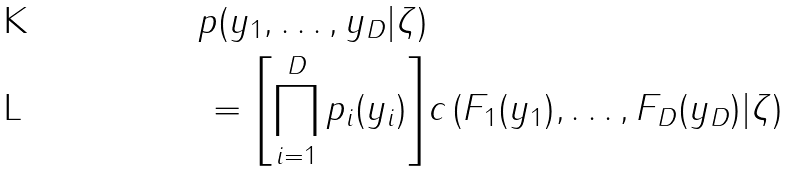Convert formula to latex. <formula><loc_0><loc_0><loc_500><loc_500>p ( y _ { 1 } , \dots , y _ { D } | \zeta ) \\ = \left [ \prod _ { i = 1 } ^ { D } p _ { i } ( y _ { i } ) \right ] & c \left ( F _ { 1 } ( y _ { 1 } ) , \dots , F _ { D } ( y _ { D } ) | \zeta \right )</formula> 